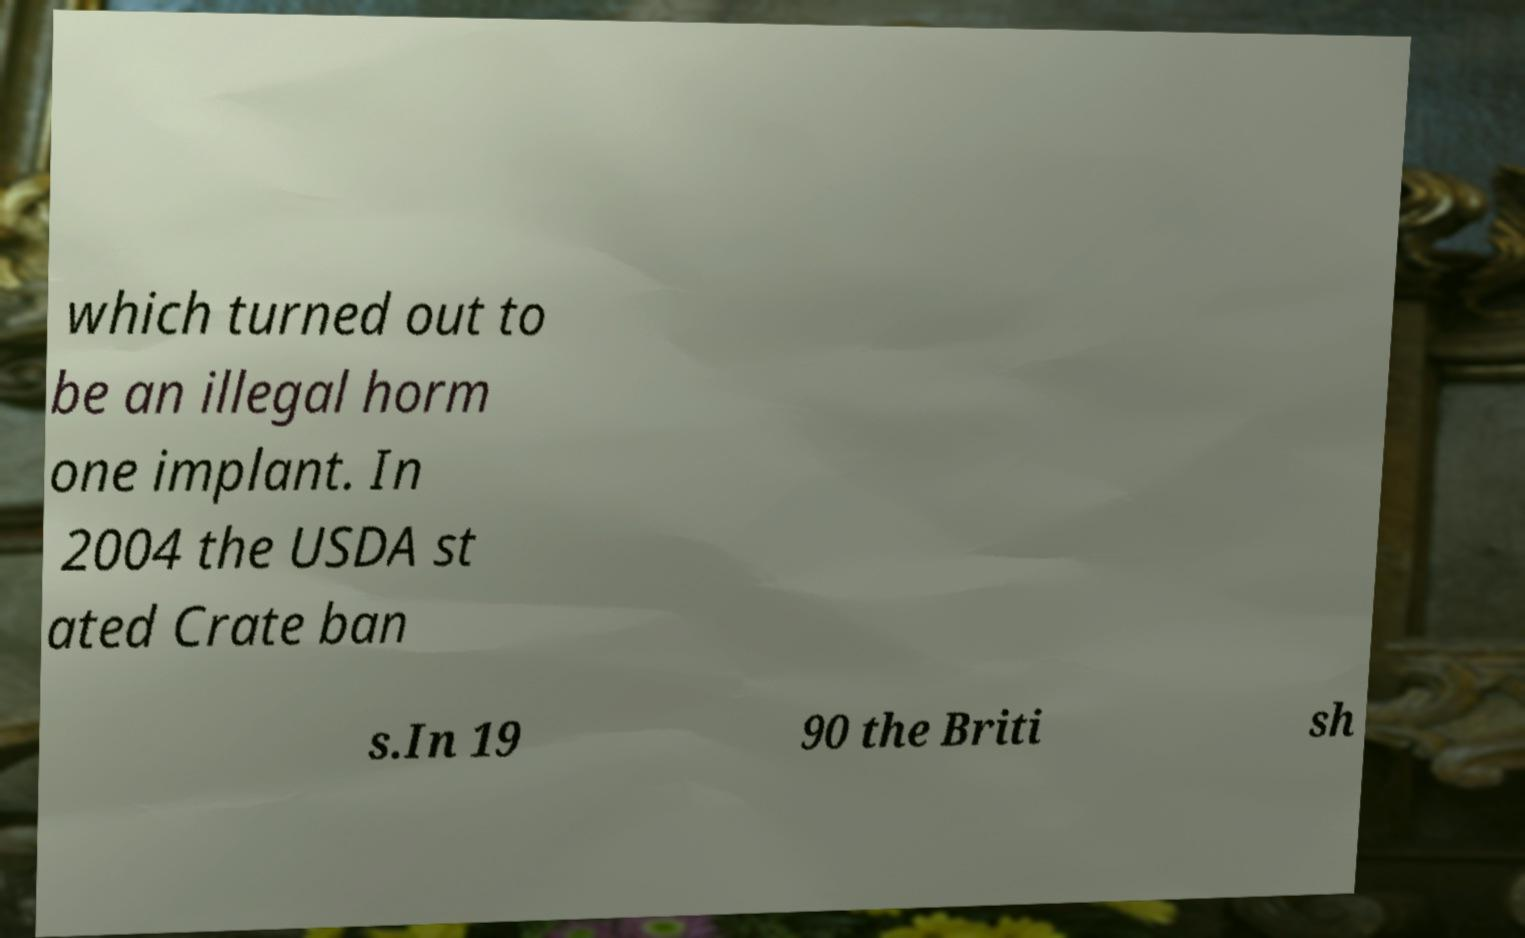Please identify and transcribe the text found in this image. which turned out to be an illegal horm one implant. In 2004 the USDA st ated Crate ban s.In 19 90 the Briti sh 